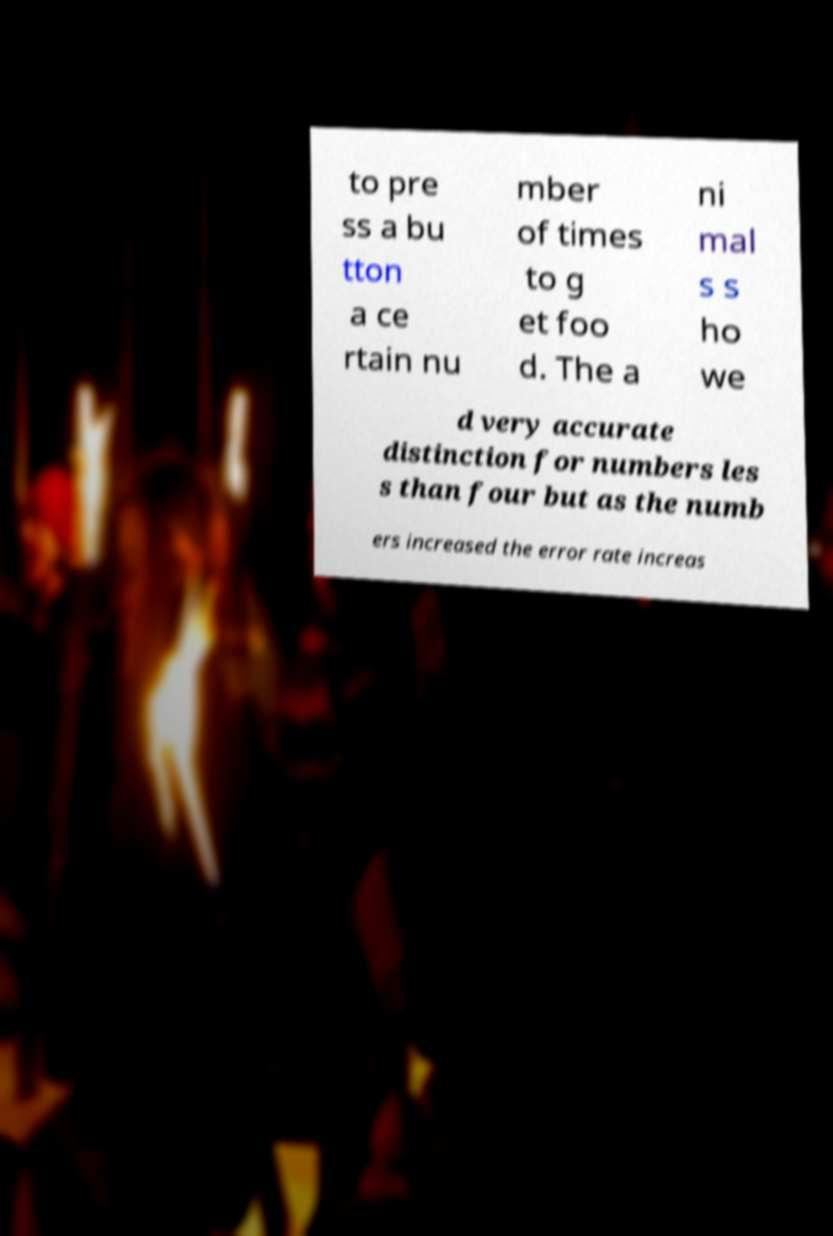What messages or text are displayed in this image? I need them in a readable, typed format. to pre ss a bu tton a ce rtain nu mber of times to g et foo d. The a ni mal s s ho we d very accurate distinction for numbers les s than four but as the numb ers increased the error rate increas 